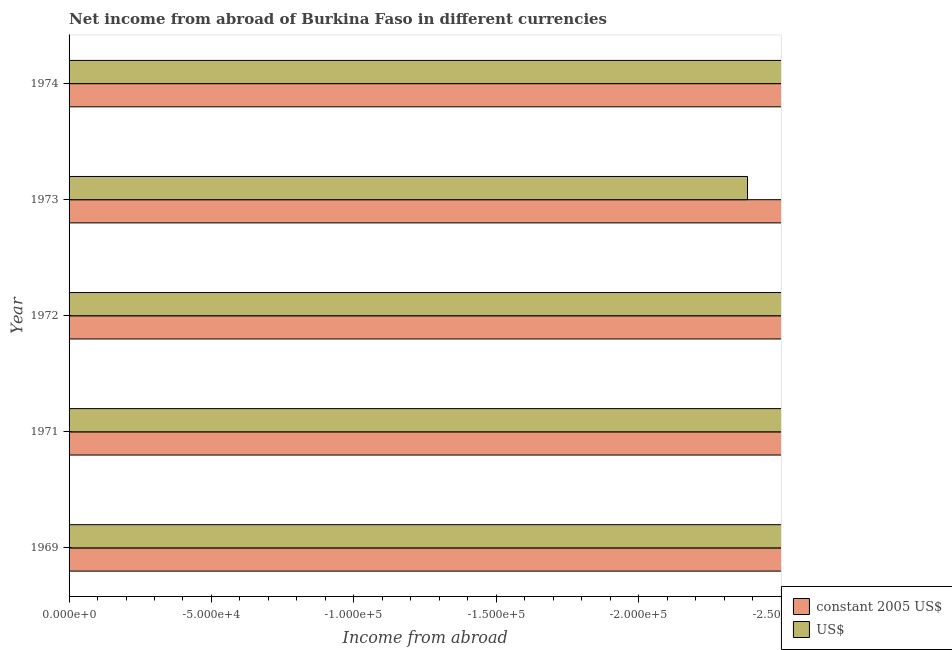How many bars are there on the 1st tick from the top?
Make the answer very short. 0. What is the total income from abroad in constant 2005 us$ in the graph?
Your response must be concise. 0. What is the difference between the income from abroad in constant 2005 us$ in 1972 and the income from abroad in us$ in 1973?
Offer a terse response. 0. What is the average income from abroad in us$ per year?
Give a very brief answer. 0. In how many years, is the income from abroad in us$ greater than -170000 units?
Provide a short and direct response. 0. In how many years, is the income from abroad in constant 2005 us$ greater than the average income from abroad in constant 2005 us$ taken over all years?
Ensure brevity in your answer.  0. How many bars are there?
Your answer should be very brief. 0. How many years are there in the graph?
Your response must be concise. 5. Does the graph contain grids?
Offer a terse response. No. Where does the legend appear in the graph?
Provide a succinct answer. Bottom right. What is the title of the graph?
Your answer should be very brief. Net income from abroad of Burkina Faso in different currencies. Does "Females" appear as one of the legend labels in the graph?
Provide a short and direct response. No. What is the label or title of the X-axis?
Your answer should be compact. Income from abroad. What is the Income from abroad of constant 2005 US$ in 1969?
Your answer should be compact. 0. What is the Income from abroad in US$ in 1969?
Give a very brief answer. 0. What is the Income from abroad in constant 2005 US$ in 1971?
Make the answer very short. 0. What is the Income from abroad in US$ in 1971?
Give a very brief answer. 0. What is the Income from abroad in constant 2005 US$ in 1972?
Your answer should be compact. 0. What is the Income from abroad of US$ in 1974?
Your response must be concise. 0. What is the total Income from abroad of constant 2005 US$ in the graph?
Keep it short and to the point. 0. What is the total Income from abroad of US$ in the graph?
Your response must be concise. 0. What is the average Income from abroad in US$ per year?
Your answer should be very brief. 0. 